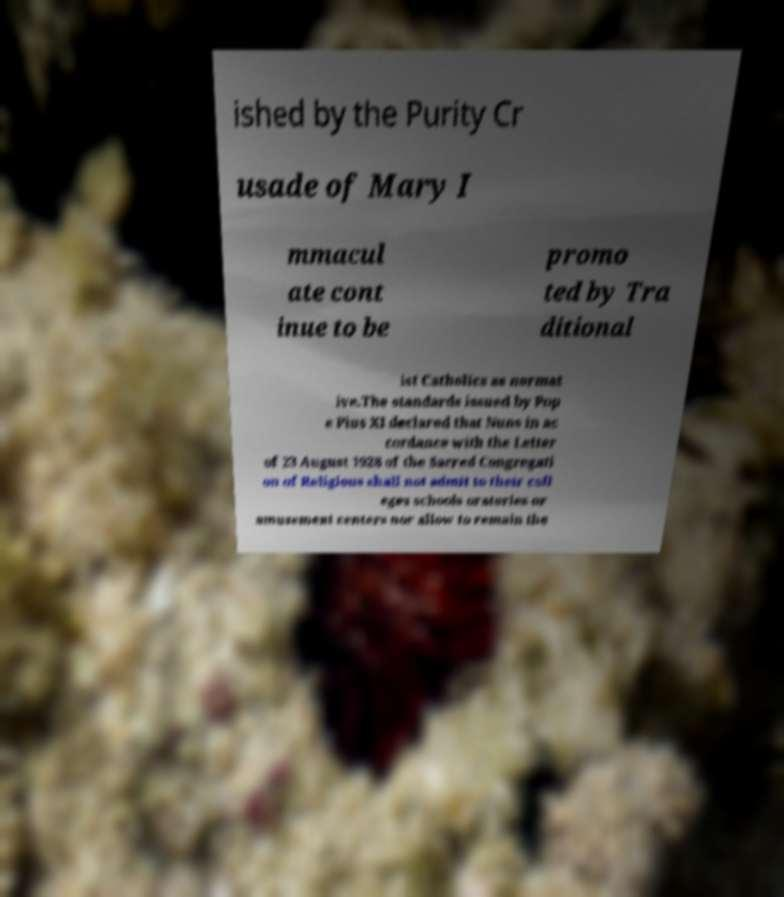Can you read and provide the text displayed in the image?This photo seems to have some interesting text. Can you extract and type it out for me? ished by the Purity Cr usade of Mary I mmacul ate cont inue to be promo ted by Tra ditional ist Catholics as normat ive.The standards issued by Pop e Pius XI declared that Nuns in ac cordance with the Letter of 23 August 1928 of the Sacred Congregati on of Religious shall not admit to their coll eges schools oratories or amusement centers nor allow to remain the 